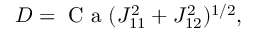<formula> <loc_0><loc_0><loc_500><loc_500>D = C a ( J _ { 1 1 } ^ { 2 } + J _ { 1 2 } ^ { 2 } ) ^ { 1 / 2 } ,</formula> 